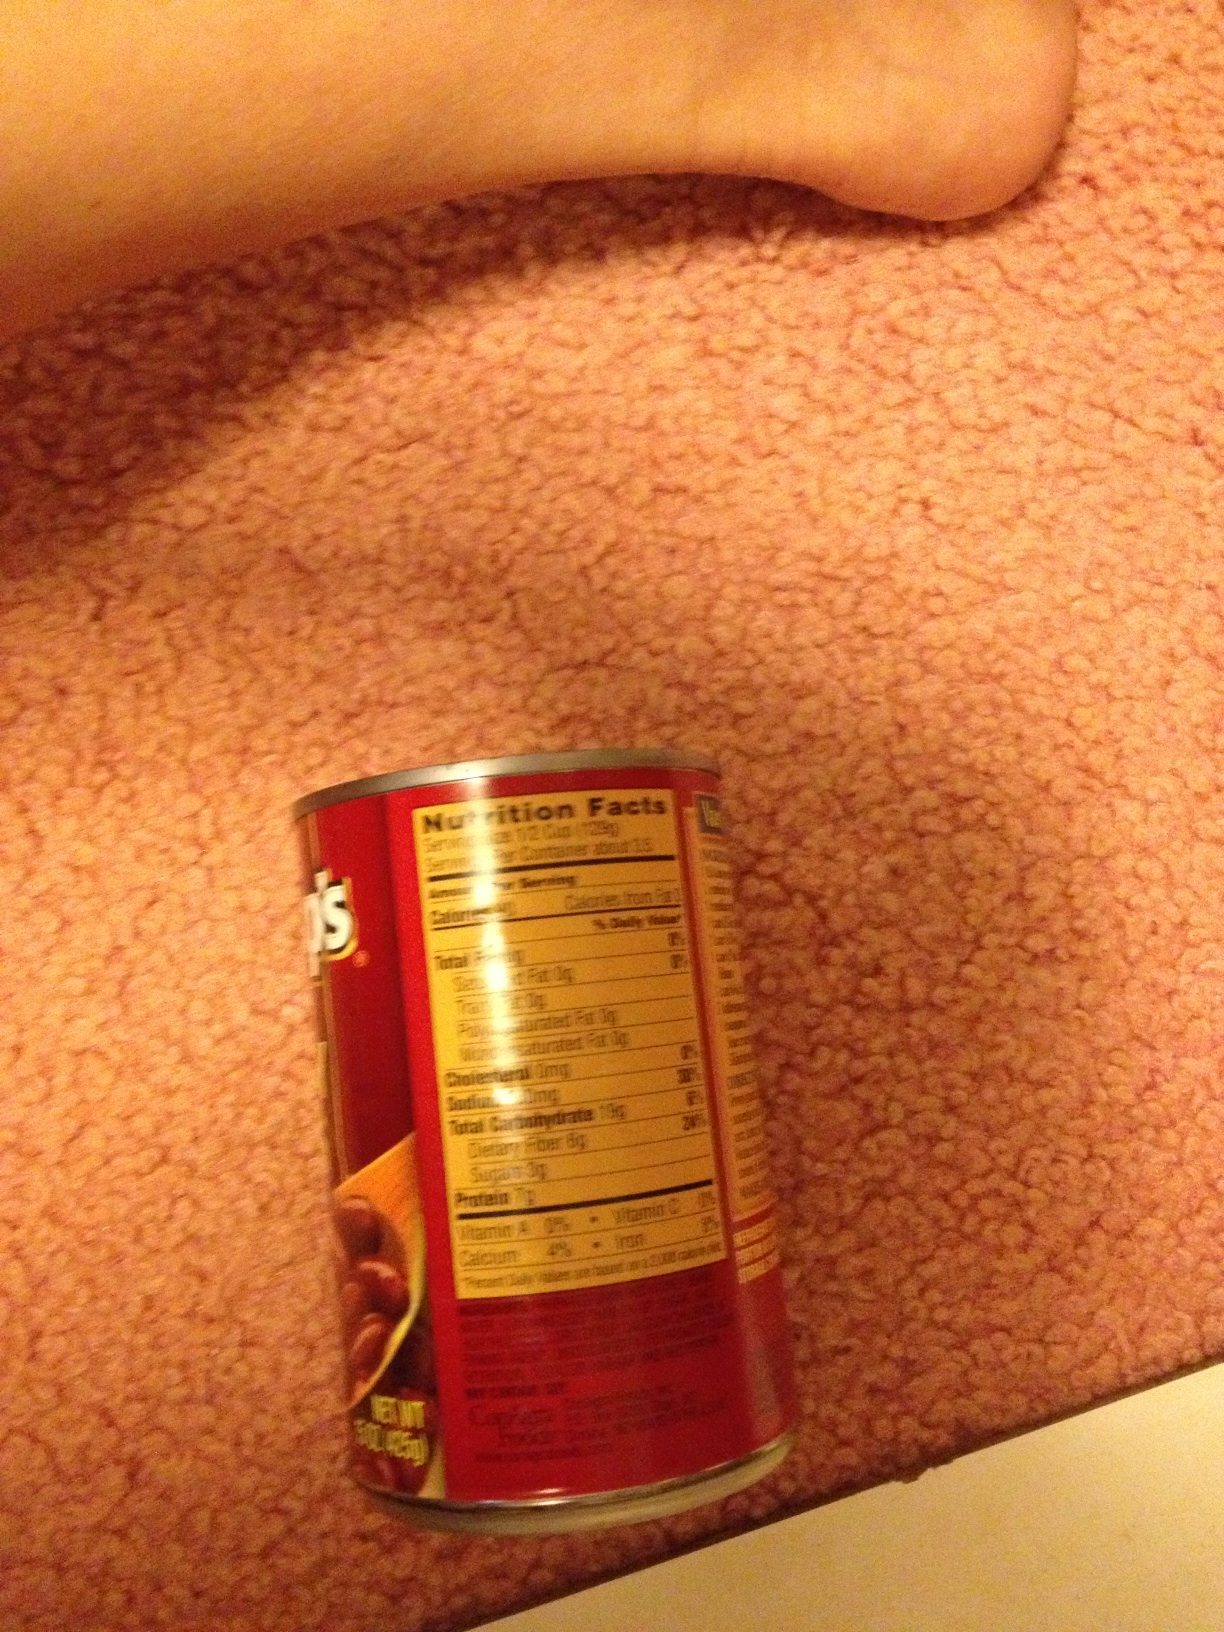What is this? This is a can of beans. The can is laying on a carpet, and you can see a part of a foot in the image as well. The nutritional information on the can label indicates it is a food product. 